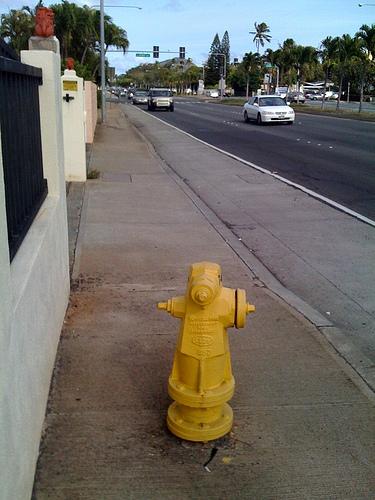Are there any palm trees?
Quick response, please. Yes. What color is the fire hydrant?
Quick response, please. Yellow. Is this a city in California?
Short answer required. Yes. 